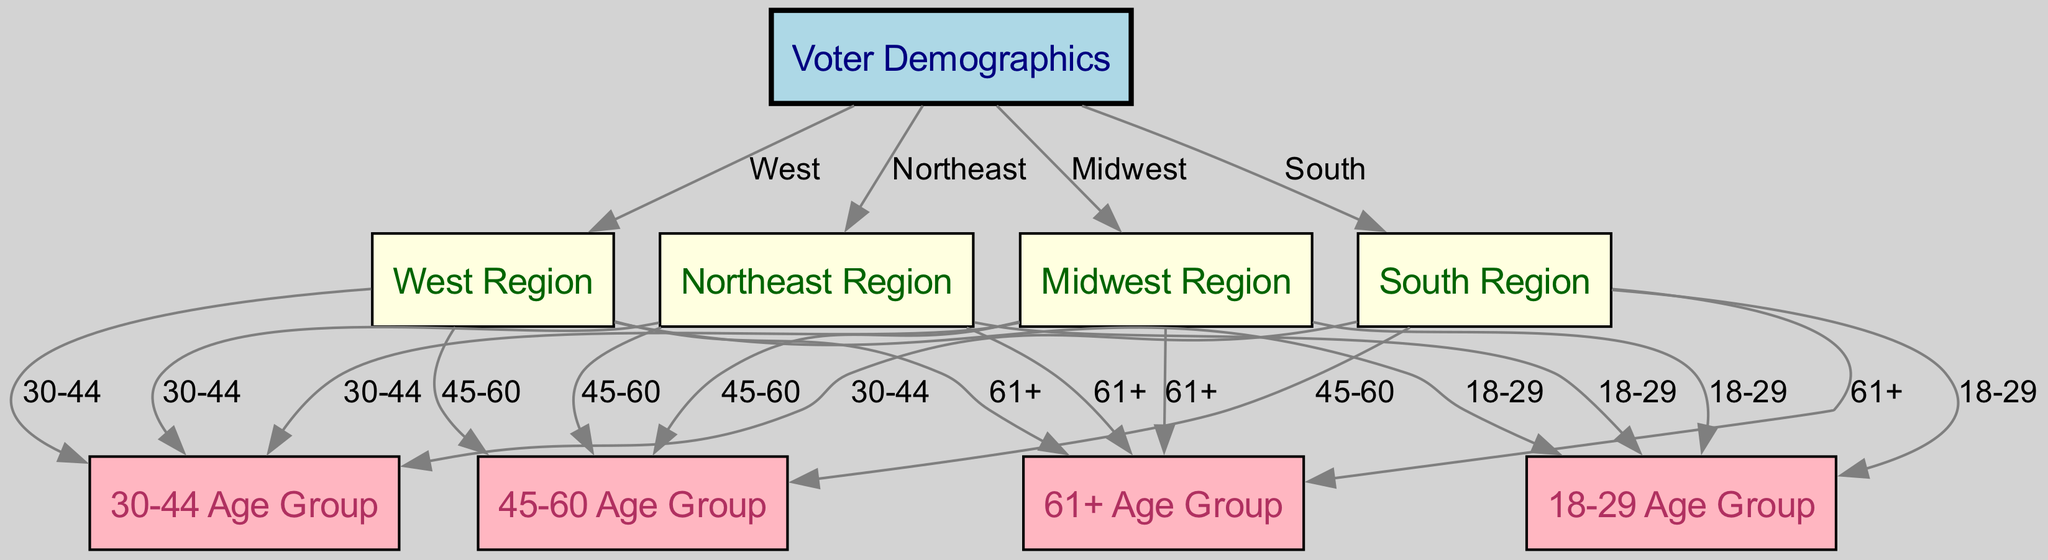What is the total number of age groups represented in the diagram? The diagram features four specific age groups: 18-29, 30-44, 45-60, and 61+. By counting these age groups, we can determine the total displayed.
Answer: 4 Which region is linked to the 30-44 age group? The diagram shows edges connecting the region nodes to the age group nodes. The 30-44 age group is linked to all four regions: Northeast, Midwest, South, and West.
Answer: Northeast, Midwest, South, West How many total regions are indicated in the diagram? The diagram includes four distinct regions: Northeast, Midwest, South, and West. Simply counting these labeled nodes provides the answer.
Answer: 4 Which age group has the youngest demographic? The ages of 18-29 represent the youngest demographic group within the diagram. This is highlighted by referring directly to the age group node labels.
Answer: 18-29 Does the South Region have an older age group representation? Yes, the South Region has a connection to the 45-60 and 61+ age groups, indicating the presence of older demographics as represented by the diagram's edges.
Answer: Yes What color represents the age group nodes in the diagram? Age group nodes are filled with light pink according to the styling rules defined for the diagram. Each type of node in the diagram has a specific color, and age groups have been consistently labeled.
Answer: Light pink Which region has the strongest representation of younger voters? The Northeast Region shows connections to the 18-29 age group, indicating a presence of younger voters. Analyzing the edges from regions to age groups reveals that younger demographics are indicated specifically here.
Answer: Northeast How many total edges connect to the West Region? The West Region connects to all four age groups: 18-29, 30-44, 45-60, and 61+. Each of these connections can be verified by counting the edges emanating from the West Region in the diagram.
Answer: 4 